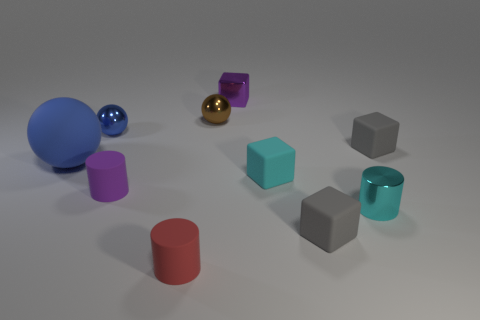Subtract all small shiny cylinders. How many cylinders are left? 2 Subtract all brown balls. How many balls are left? 2 Subtract 0 yellow cubes. How many objects are left? 10 Subtract all blocks. How many objects are left? 6 Subtract 1 blocks. How many blocks are left? 3 Subtract all cyan cubes. Subtract all blue cylinders. How many cubes are left? 3 Subtract all brown cubes. How many cyan cylinders are left? 1 Subtract all tiny cyan objects. Subtract all purple shiny blocks. How many objects are left? 7 Add 8 purple cubes. How many purple cubes are left? 9 Add 6 purple metallic things. How many purple metallic things exist? 7 